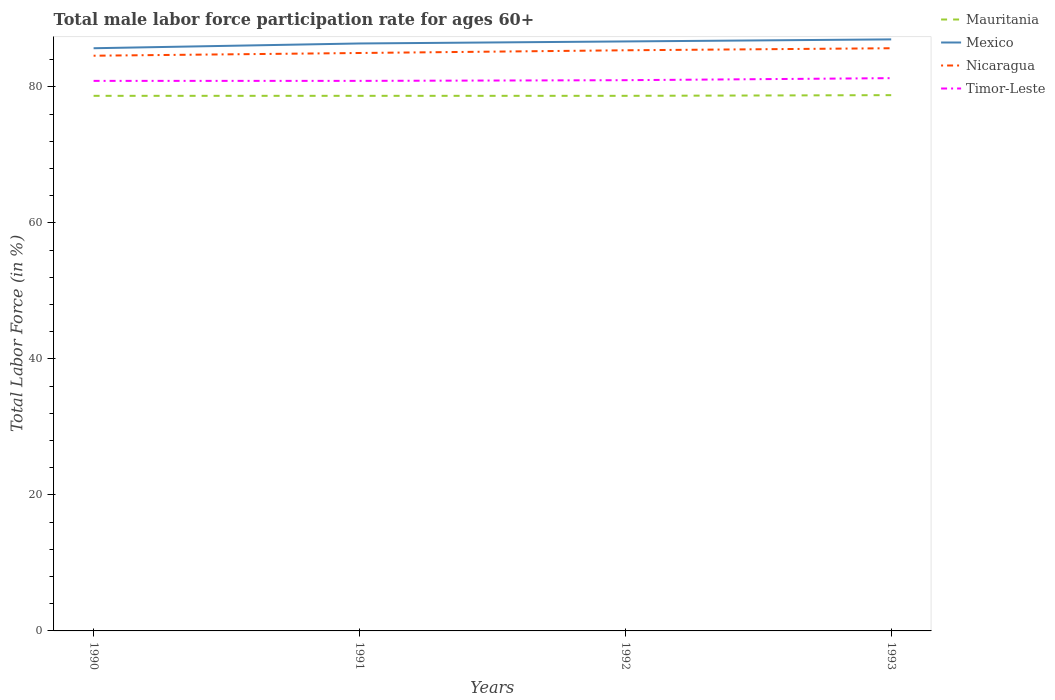Is the number of lines equal to the number of legend labels?
Your answer should be compact. Yes. Across all years, what is the maximum male labor force participation rate in Nicaragua?
Your answer should be very brief. 84.6. What is the total male labor force participation rate in Nicaragua in the graph?
Keep it short and to the point. -0.8. What is the difference between the highest and the second highest male labor force participation rate in Mexico?
Provide a succinct answer. 1.3. What is the difference between the highest and the lowest male labor force participation rate in Mexico?
Give a very brief answer. 2. Is the male labor force participation rate in Timor-Leste strictly greater than the male labor force participation rate in Nicaragua over the years?
Your answer should be very brief. Yes. How many years are there in the graph?
Keep it short and to the point. 4. What is the difference between two consecutive major ticks on the Y-axis?
Provide a succinct answer. 20. Does the graph contain any zero values?
Provide a short and direct response. No. Where does the legend appear in the graph?
Your answer should be very brief. Top right. How are the legend labels stacked?
Ensure brevity in your answer.  Vertical. What is the title of the graph?
Offer a terse response. Total male labor force participation rate for ages 60+. What is the Total Labor Force (in %) of Mauritania in 1990?
Offer a terse response. 78.7. What is the Total Labor Force (in %) in Mexico in 1990?
Keep it short and to the point. 85.7. What is the Total Labor Force (in %) in Nicaragua in 1990?
Provide a succinct answer. 84.6. What is the Total Labor Force (in %) of Timor-Leste in 1990?
Your answer should be compact. 80.9. What is the Total Labor Force (in %) in Mauritania in 1991?
Make the answer very short. 78.7. What is the Total Labor Force (in %) in Mexico in 1991?
Make the answer very short. 86.4. What is the Total Labor Force (in %) of Timor-Leste in 1991?
Keep it short and to the point. 80.9. What is the Total Labor Force (in %) in Mauritania in 1992?
Your response must be concise. 78.7. What is the Total Labor Force (in %) in Mexico in 1992?
Your answer should be compact. 86.7. What is the Total Labor Force (in %) of Nicaragua in 1992?
Provide a short and direct response. 85.4. What is the Total Labor Force (in %) in Timor-Leste in 1992?
Keep it short and to the point. 81. What is the Total Labor Force (in %) in Mauritania in 1993?
Your response must be concise. 78.8. What is the Total Labor Force (in %) in Mexico in 1993?
Offer a very short reply. 87. What is the Total Labor Force (in %) in Nicaragua in 1993?
Your response must be concise. 85.7. What is the Total Labor Force (in %) in Timor-Leste in 1993?
Offer a very short reply. 81.3. Across all years, what is the maximum Total Labor Force (in %) of Mauritania?
Make the answer very short. 78.8. Across all years, what is the maximum Total Labor Force (in %) in Mexico?
Offer a terse response. 87. Across all years, what is the maximum Total Labor Force (in %) in Nicaragua?
Offer a very short reply. 85.7. Across all years, what is the maximum Total Labor Force (in %) in Timor-Leste?
Your answer should be compact. 81.3. Across all years, what is the minimum Total Labor Force (in %) in Mauritania?
Provide a short and direct response. 78.7. Across all years, what is the minimum Total Labor Force (in %) in Mexico?
Your answer should be compact. 85.7. Across all years, what is the minimum Total Labor Force (in %) in Nicaragua?
Offer a very short reply. 84.6. Across all years, what is the minimum Total Labor Force (in %) in Timor-Leste?
Offer a terse response. 80.9. What is the total Total Labor Force (in %) in Mauritania in the graph?
Make the answer very short. 314.9. What is the total Total Labor Force (in %) of Mexico in the graph?
Your answer should be compact. 345.8. What is the total Total Labor Force (in %) of Nicaragua in the graph?
Provide a succinct answer. 340.7. What is the total Total Labor Force (in %) in Timor-Leste in the graph?
Offer a very short reply. 324.1. What is the difference between the Total Labor Force (in %) in Mauritania in 1990 and that in 1991?
Your answer should be compact. 0. What is the difference between the Total Labor Force (in %) of Mexico in 1990 and that in 1991?
Your answer should be compact. -0.7. What is the difference between the Total Labor Force (in %) in Nicaragua in 1990 and that in 1991?
Offer a very short reply. -0.4. What is the difference between the Total Labor Force (in %) in Mauritania in 1990 and that in 1992?
Keep it short and to the point. 0. What is the difference between the Total Labor Force (in %) in Mexico in 1990 and that in 1992?
Provide a succinct answer. -1. What is the difference between the Total Labor Force (in %) of Nicaragua in 1990 and that in 1992?
Provide a succinct answer. -0.8. What is the difference between the Total Labor Force (in %) in Mauritania in 1990 and that in 1993?
Provide a short and direct response. -0.1. What is the difference between the Total Labor Force (in %) of Mexico in 1990 and that in 1993?
Ensure brevity in your answer.  -1.3. What is the difference between the Total Labor Force (in %) in Mauritania in 1991 and that in 1992?
Ensure brevity in your answer.  0. What is the difference between the Total Labor Force (in %) in Nicaragua in 1991 and that in 1992?
Give a very brief answer. -0.4. What is the difference between the Total Labor Force (in %) in Mauritania in 1991 and that in 1993?
Your answer should be very brief. -0.1. What is the difference between the Total Labor Force (in %) in Nicaragua in 1991 and that in 1993?
Your answer should be compact. -0.7. What is the difference between the Total Labor Force (in %) in Timor-Leste in 1991 and that in 1993?
Make the answer very short. -0.4. What is the difference between the Total Labor Force (in %) in Mexico in 1990 and the Total Labor Force (in %) in Nicaragua in 1991?
Offer a terse response. 0.7. What is the difference between the Total Labor Force (in %) of Mauritania in 1990 and the Total Labor Force (in %) of Nicaragua in 1992?
Provide a short and direct response. -6.7. What is the difference between the Total Labor Force (in %) in Mauritania in 1990 and the Total Labor Force (in %) in Timor-Leste in 1992?
Offer a terse response. -2.3. What is the difference between the Total Labor Force (in %) of Mexico in 1990 and the Total Labor Force (in %) of Nicaragua in 1992?
Make the answer very short. 0.3. What is the difference between the Total Labor Force (in %) of Mexico in 1990 and the Total Labor Force (in %) of Timor-Leste in 1992?
Keep it short and to the point. 4.7. What is the difference between the Total Labor Force (in %) in Mauritania in 1991 and the Total Labor Force (in %) in Mexico in 1992?
Provide a succinct answer. -8. What is the difference between the Total Labor Force (in %) of Mexico in 1991 and the Total Labor Force (in %) of Nicaragua in 1993?
Offer a very short reply. 0.7. What is the difference between the Total Labor Force (in %) in Mauritania in 1992 and the Total Labor Force (in %) in Mexico in 1993?
Ensure brevity in your answer.  -8.3. What is the difference between the Total Labor Force (in %) of Mexico in 1992 and the Total Labor Force (in %) of Nicaragua in 1993?
Provide a succinct answer. 1. What is the difference between the Total Labor Force (in %) in Mexico in 1992 and the Total Labor Force (in %) in Timor-Leste in 1993?
Provide a short and direct response. 5.4. What is the average Total Labor Force (in %) in Mauritania per year?
Your response must be concise. 78.72. What is the average Total Labor Force (in %) of Mexico per year?
Keep it short and to the point. 86.45. What is the average Total Labor Force (in %) in Nicaragua per year?
Provide a succinct answer. 85.17. What is the average Total Labor Force (in %) in Timor-Leste per year?
Your response must be concise. 81.03. In the year 1990, what is the difference between the Total Labor Force (in %) of Mauritania and Total Labor Force (in %) of Timor-Leste?
Your answer should be very brief. -2.2. In the year 1990, what is the difference between the Total Labor Force (in %) of Mexico and Total Labor Force (in %) of Timor-Leste?
Provide a short and direct response. 4.8. In the year 1991, what is the difference between the Total Labor Force (in %) in Mauritania and Total Labor Force (in %) in Mexico?
Provide a short and direct response. -7.7. In the year 1991, what is the difference between the Total Labor Force (in %) of Mauritania and Total Labor Force (in %) of Nicaragua?
Offer a very short reply. -6.3. In the year 1991, what is the difference between the Total Labor Force (in %) of Mauritania and Total Labor Force (in %) of Timor-Leste?
Offer a very short reply. -2.2. In the year 1991, what is the difference between the Total Labor Force (in %) of Mexico and Total Labor Force (in %) of Nicaragua?
Keep it short and to the point. 1.4. In the year 1991, what is the difference between the Total Labor Force (in %) in Mexico and Total Labor Force (in %) in Timor-Leste?
Your response must be concise. 5.5. In the year 1991, what is the difference between the Total Labor Force (in %) of Nicaragua and Total Labor Force (in %) of Timor-Leste?
Give a very brief answer. 4.1. In the year 1992, what is the difference between the Total Labor Force (in %) in Mauritania and Total Labor Force (in %) in Mexico?
Make the answer very short. -8. In the year 1992, what is the difference between the Total Labor Force (in %) of Mauritania and Total Labor Force (in %) of Nicaragua?
Keep it short and to the point. -6.7. In the year 1992, what is the difference between the Total Labor Force (in %) of Mauritania and Total Labor Force (in %) of Timor-Leste?
Your answer should be very brief. -2.3. In the year 1992, what is the difference between the Total Labor Force (in %) in Mexico and Total Labor Force (in %) in Timor-Leste?
Your answer should be very brief. 5.7. In the year 1993, what is the difference between the Total Labor Force (in %) of Mauritania and Total Labor Force (in %) of Nicaragua?
Make the answer very short. -6.9. In the year 1993, what is the difference between the Total Labor Force (in %) of Mexico and Total Labor Force (in %) of Nicaragua?
Your response must be concise. 1.3. In the year 1993, what is the difference between the Total Labor Force (in %) in Nicaragua and Total Labor Force (in %) in Timor-Leste?
Offer a very short reply. 4.4. What is the ratio of the Total Labor Force (in %) in Mauritania in 1990 to that in 1991?
Offer a terse response. 1. What is the ratio of the Total Labor Force (in %) of Mexico in 1990 to that in 1991?
Give a very brief answer. 0.99. What is the ratio of the Total Labor Force (in %) of Nicaragua in 1990 to that in 1992?
Keep it short and to the point. 0.99. What is the ratio of the Total Labor Force (in %) in Mauritania in 1990 to that in 1993?
Your answer should be very brief. 1. What is the ratio of the Total Labor Force (in %) of Mexico in 1990 to that in 1993?
Provide a short and direct response. 0.99. What is the ratio of the Total Labor Force (in %) of Nicaragua in 1990 to that in 1993?
Offer a terse response. 0.99. What is the ratio of the Total Labor Force (in %) in Mexico in 1991 to that in 1992?
Provide a short and direct response. 1. What is the ratio of the Total Labor Force (in %) in Nicaragua in 1991 to that in 1992?
Offer a terse response. 1. What is the ratio of the Total Labor Force (in %) of Nicaragua in 1992 to that in 1993?
Ensure brevity in your answer.  1. What is the ratio of the Total Labor Force (in %) in Timor-Leste in 1992 to that in 1993?
Offer a very short reply. 1. What is the difference between the highest and the second highest Total Labor Force (in %) of Mauritania?
Give a very brief answer. 0.1. What is the difference between the highest and the lowest Total Labor Force (in %) in Timor-Leste?
Your answer should be compact. 0.4. 